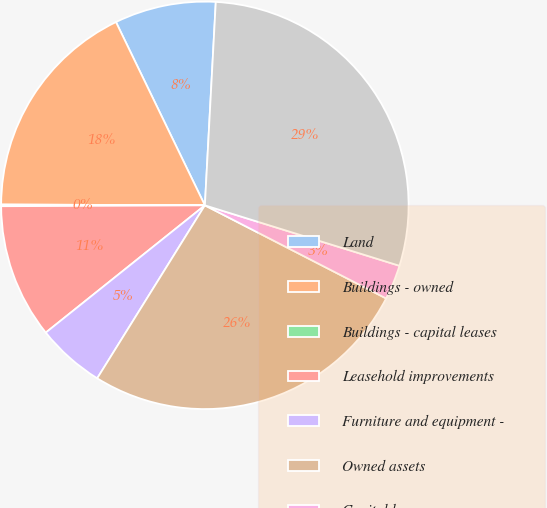Convert chart to OTSL. <chart><loc_0><loc_0><loc_500><loc_500><pie_chart><fcel>Land<fcel>Buildings - owned<fcel>Buildings - capital leases<fcel>Leasehold improvements<fcel>Furniture and equipment -<fcel>Owned assets<fcel>Capital leases<fcel>Premises and equipment net<nl><fcel>8.04%<fcel>17.75%<fcel>0.13%<fcel>10.67%<fcel>5.4%<fcel>26.31%<fcel>2.76%<fcel>28.94%<nl></chart> 